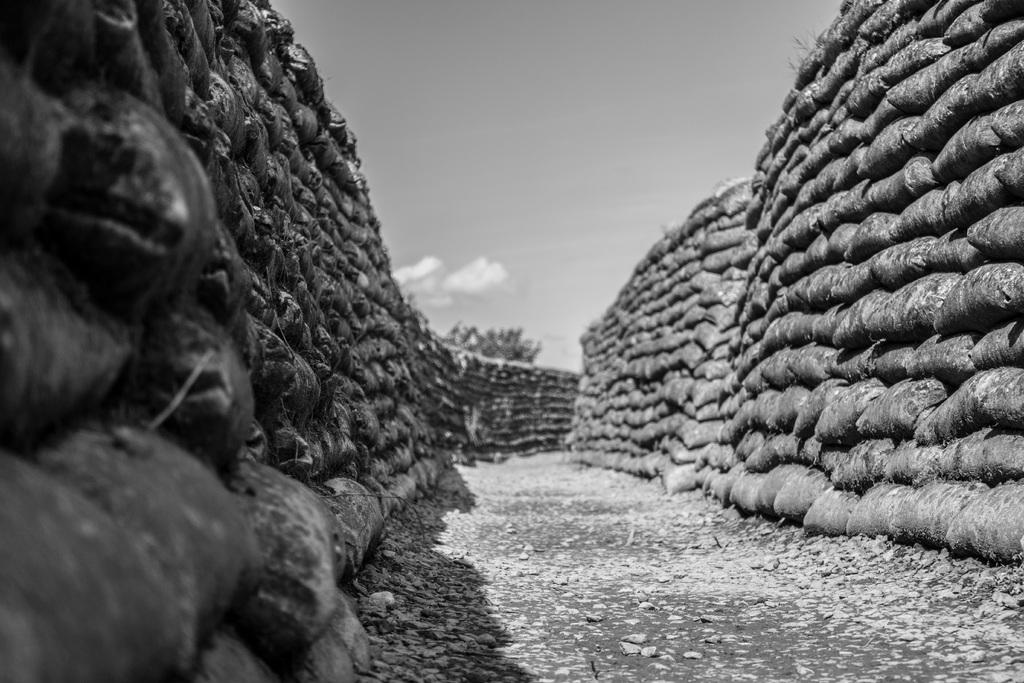What is the color scheme of the image? The image is black and white. What objects can be seen in the image? There are bags in the image. How are the bags arranged in the image? The bags are stacked one on top of another. What is visible beneath the bags in the image? There is ground visible in the image. What is visible in the background of the image? The sky is visible in the background of the image. What type of collar can be seen on the mom in the image? There is no mom or collar present in the image; it features bags stacked on top of each other. 